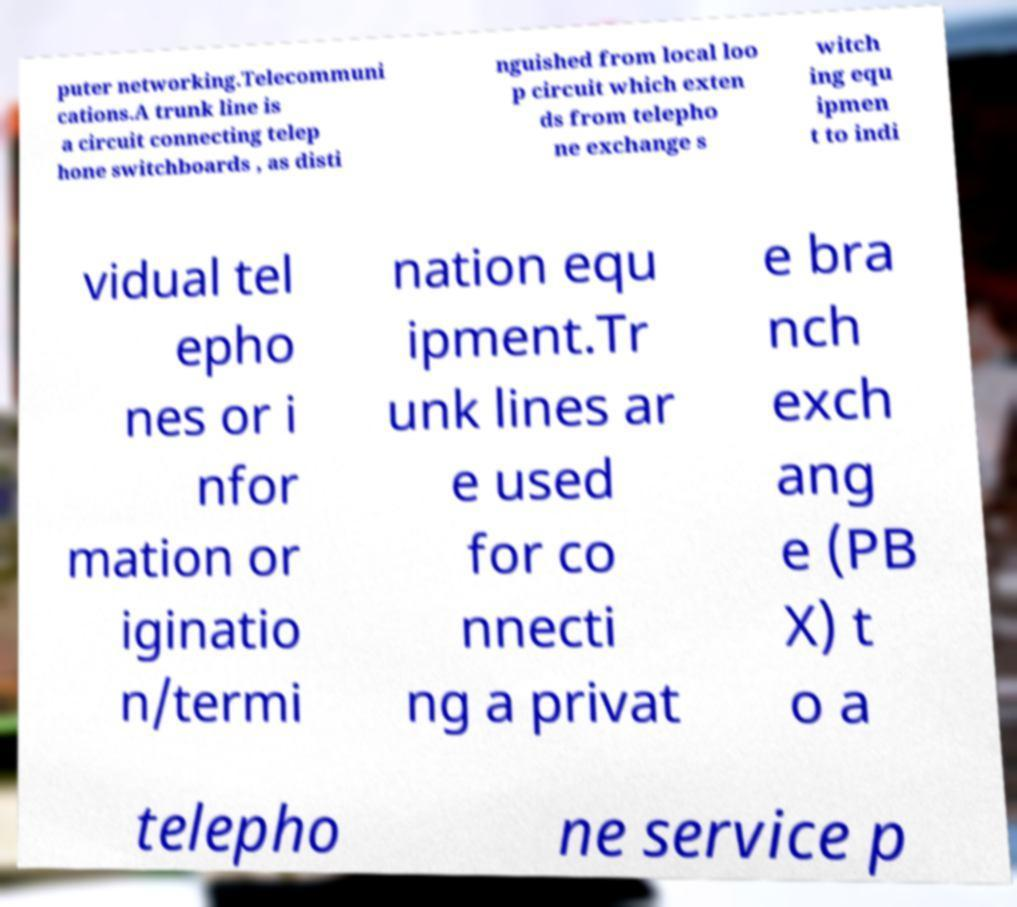Could you extract and type out the text from this image? puter networking.Telecommuni cations.A trunk line is a circuit connecting telep hone switchboards , as disti nguished from local loo p circuit which exten ds from telepho ne exchange s witch ing equ ipmen t to indi vidual tel epho nes or i nfor mation or iginatio n/termi nation equ ipment.Tr unk lines ar e used for co nnecti ng a privat e bra nch exch ang e (PB X) t o a telepho ne service p 